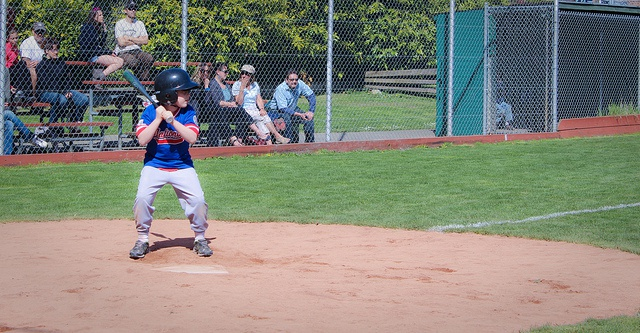Describe the objects in this image and their specific colors. I can see people in gray, lavender, black, navy, and darkgray tones, people in gray, black, navy, and blue tones, people in gray and lightblue tones, people in gray, black, darkgray, and navy tones, and people in gray, lightgray, darkgray, and black tones in this image. 